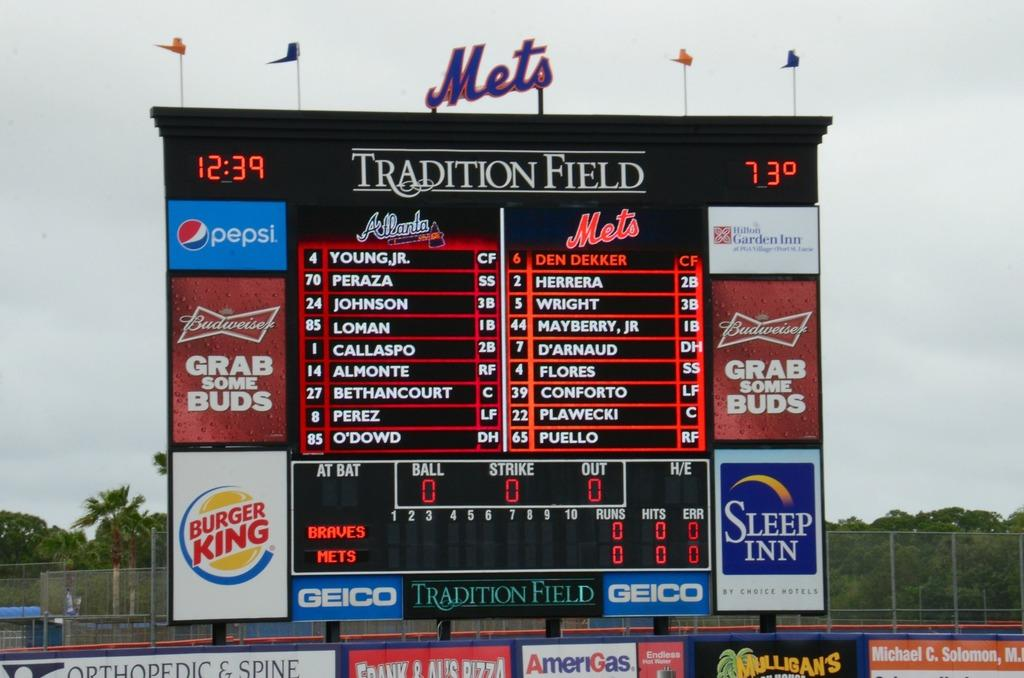<image>
Describe the image concisely. The scoreboard for Tradition Field shows the lineup for the Mets and Atlanta Braves baseball teams. 